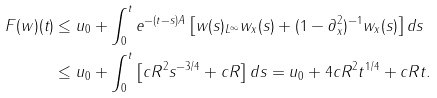<formula> <loc_0><loc_0><loc_500><loc_500>\| F ( w ) ( t ) \| & \leq \| u _ { 0 } \| + \int _ { 0 } ^ { t } \| e ^ { - ( t - s ) A } \| \left [ \| w ( s ) \| _ { L ^ { \infty } } \| w _ { x } ( s ) \| + \| ( 1 - \partial _ { x } ^ { 2 } ) ^ { - 1 } w _ { x } ( s ) \| \right ] d s \\ & \leq \| u _ { 0 } \| + \int _ { 0 } ^ { t } \left [ c R ^ { 2 } s ^ { - 3 / 4 } + c R \right ] d s = \| u _ { 0 } \| + 4 c R ^ { 2 } t ^ { 1 / 4 } + c R t .</formula> 